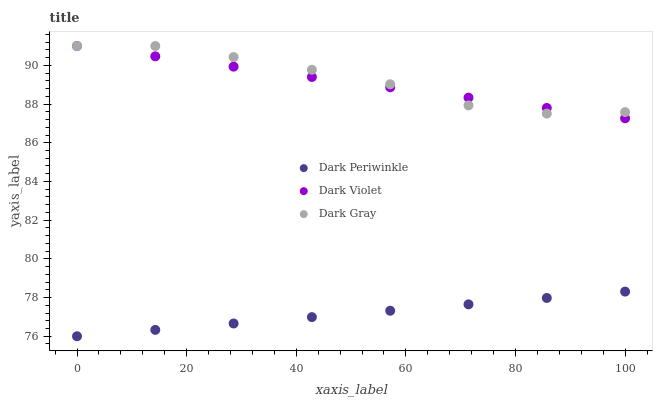Does Dark Periwinkle have the minimum area under the curve?
Answer yes or no. Yes. Does Dark Gray have the maximum area under the curve?
Answer yes or no. Yes. Does Dark Violet have the minimum area under the curve?
Answer yes or no. No. Does Dark Violet have the maximum area under the curve?
Answer yes or no. No. Is Dark Periwinkle the smoothest?
Answer yes or no. Yes. Is Dark Gray the roughest?
Answer yes or no. Yes. Is Dark Violet the smoothest?
Answer yes or no. No. Is Dark Violet the roughest?
Answer yes or no. No. Does Dark Periwinkle have the lowest value?
Answer yes or no. Yes. Does Dark Violet have the lowest value?
Answer yes or no. No. Does Dark Violet have the highest value?
Answer yes or no. Yes. Does Dark Periwinkle have the highest value?
Answer yes or no. No. Is Dark Periwinkle less than Dark Gray?
Answer yes or no. Yes. Is Dark Violet greater than Dark Periwinkle?
Answer yes or no. Yes. Does Dark Violet intersect Dark Gray?
Answer yes or no. Yes. Is Dark Violet less than Dark Gray?
Answer yes or no. No. Is Dark Violet greater than Dark Gray?
Answer yes or no. No. Does Dark Periwinkle intersect Dark Gray?
Answer yes or no. No. 